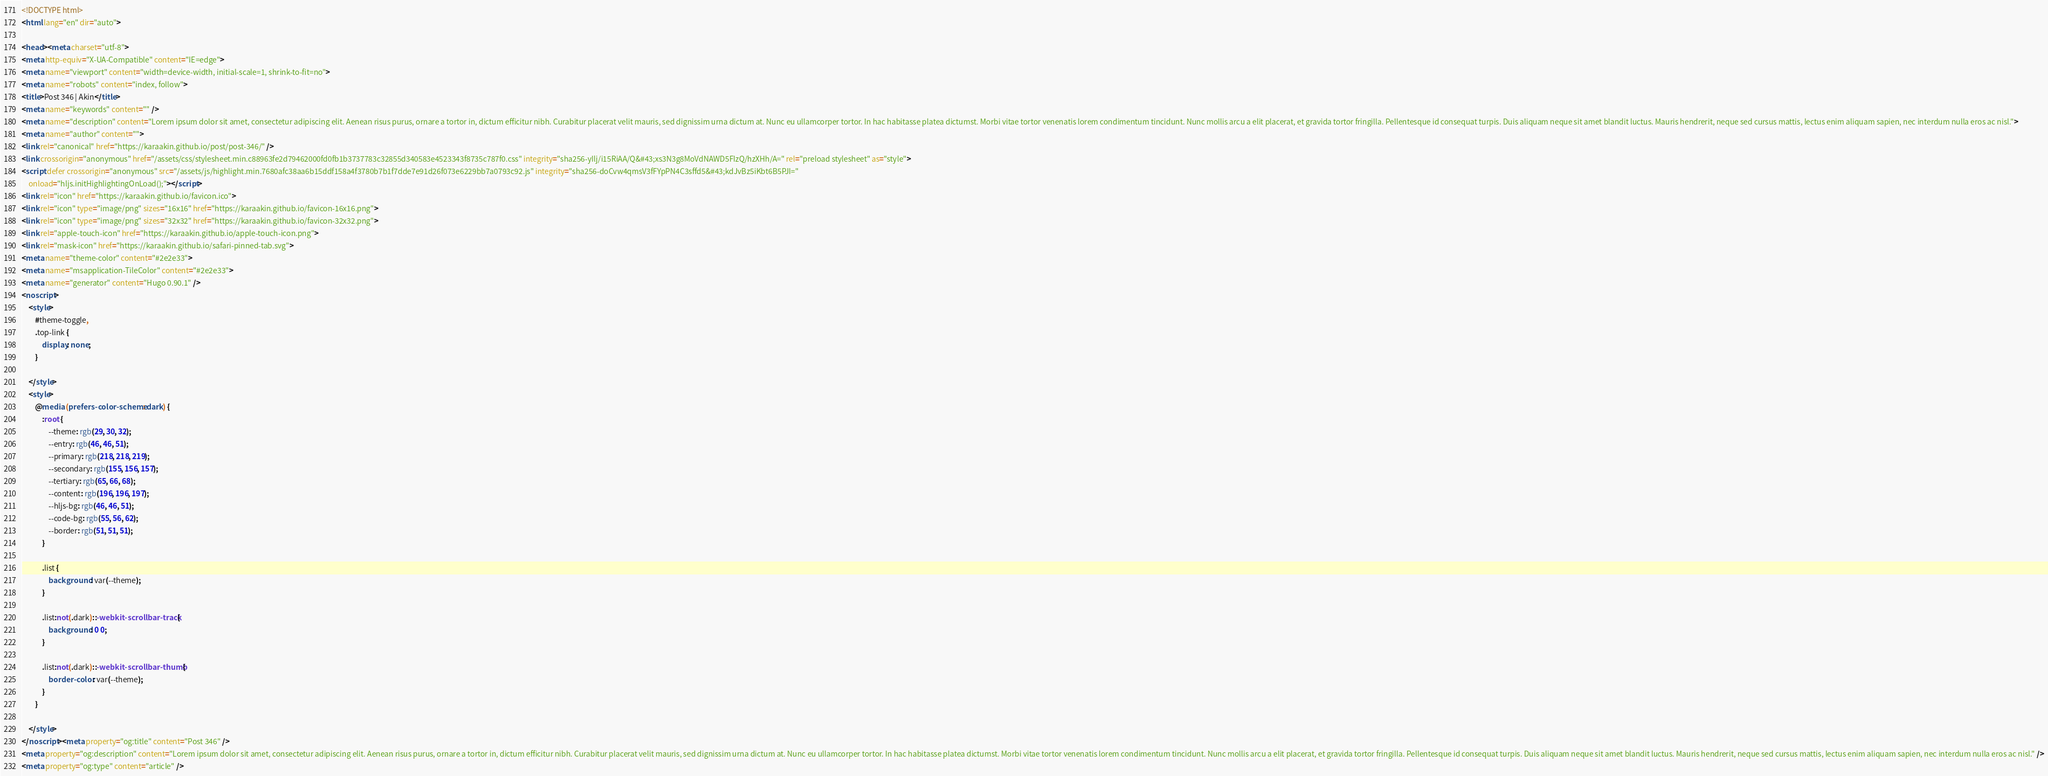Convert code to text. <code><loc_0><loc_0><loc_500><loc_500><_HTML_><!DOCTYPE html>
<html lang="en" dir="auto">

<head><meta charset="utf-8">
<meta http-equiv="X-UA-Compatible" content="IE=edge">
<meta name="viewport" content="width=device-width, initial-scale=1, shrink-to-fit=no">
<meta name="robots" content="index, follow">
<title>Post 346 | Akin</title>
<meta name="keywords" content="" />
<meta name="description" content="Lorem ipsum dolor sit amet, consectetur adipiscing elit. Aenean risus purus, ornare a tortor in, dictum efficitur nibh. Curabitur placerat velit mauris, sed dignissim urna dictum at. Nunc eu ullamcorper tortor. In hac habitasse platea dictumst. Morbi vitae tortor venenatis lorem condimentum tincidunt. Nunc mollis arcu a elit placerat, et gravida tortor fringilla. Pellentesque id consequat turpis. Duis aliquam neque sit amet blandit luctus. Mauris hendrerit, neque sed cursus mattis, lectus enim aliquam sapien, nec interdum nulla eros ac nisl.">
<meta name="author" content="">
<link rel="canonical" href="https://karaakin.github.io/post/post-346/" />
<link crossorigin="anonymous" href="/assets/css/stylesheet.min.c88963fe2d79462000fd0fb1b3737783c32855d340583e4523343f8735c787f0.css" integrity="sha256-yIlj/i15RiAA/Q&#43;xs3N3g8MoVdNAWD5FIzQ/hzXHh/A=" rel="preload stylesheet" as="style">
<script defer crossorigin="anonymous" src="/assets/js/highlight.min.7680afc38aa6b15ddf158a4f3780b7b1f7dde7e91d26f073e6229bb7a0793c92.js" integrity="sha256-doCvw4qmsV3fFYpPN4C3sffd5&#43;kdJvBz5iKbt6B5PJI="
    onload="hljs.initHighlightingOnLoad();"></script>
<link rel="icon" href="https://karaakin.github.io/favicon.ico">
<link rel="icon" type="image/png" sizes="16x16" href="https://karaakin.github.io/favicon-16x16.png">
<link rel="icon" type="image/png" sizes="32x32" href="https://karaakin.github.io/favicon-32x32.png">
<link rel="apple-touch-icon" href="https://karaakin.github.io/apple-touch-icon.png">
<link rel="mask-icon" href="https://karaakin.github.io/safari-pinned-tab.svg">
<meta name="theme-color" content="#2e2e33">
<meta name="msapplication-TileColor" content="#2e2e33">
<meta name="generator" content="Hugo 0.90.1" />
<noscript>
    <style>
        #theme-toggle,
        .top-link {
            display: none;
        }

    </style>
    <style>
        @media (prefers-color-scheme: dark) {
            :root {
                --theme: rgb(29, 30, 32);
                --entry: rgb(46, 46, 51);
                --primary: rgb(218, 218, 219);
                --secondary: rgb(155, 156, 157);
                --tertiary: rgb(65, 66, 68);
                --content: rgb(196, 196, 197);
                --hljs-bg: rgb(46, 46, 51);
                --code-bg: rgb(55, 56, 62);
                --border: rgb(51, 51, 51);
            }

            .list {
                background: var(--theme);
            }

            .list:not(.dark)::-webkit-scrollbar-track {
                background: 0 0;
            }

            .list:not(.dark)::-webkit-scrollbar-thumb {
                border-color: var(--theme);
            }
        }

    </style>
</noscript><meta property="og:title" content="Post 346" />
<meta property="og:description" content="Lorem ipsum dolor sit amet, consectetur adipiscing elit. Aenean risus purus, ornare a tortor in, dictum efficitur nibh. Curabitur placerat velit mauris, sed dignissim urna dictum at. Nunc eu ullamcorper tortor. In hac habitasse platea dictumst. Morbi vitae tortor venenatis lorem condimentum tincidunt. Nunc mollis arcu a elit placerat, et gravida tortor fringilla. Pellentesque id consequat turpis. Duis aliquam neque sit amet blandit luctus. Mauris hendrerit, neque sed cursus mattis, lectus enim aliquam sapien, nec interdum nulla eros ac nisl." />
<meta property="og:type" content="article" /></code> 